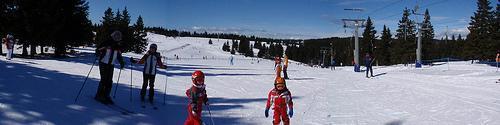How many children are holding poles?
Give a very brief answer. 1. How many children are skiing?
Give a very brief answer. 2. 